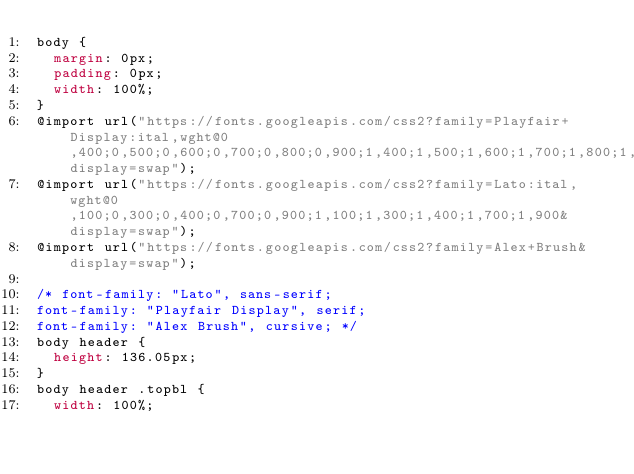Convert code to text. <code><loc_0><loc_0><loc_500><loc_500><_CSS_>body {
  margin: 0px;
  padding: 0px;
  width: 100%;
}
@import url("https://fonts.googleapis.com/css2?family=Playfair+Display:ital,wght@0,400;0,500;0,600;0,700;0,800;0,900;1,400;1,500;1,600;1,700;1,800;1,900&display=swap");
@import url("https://fonts.googleapis.com/css2?family=Lato:ital,wght@0,100;0,300;0,400;0,700;0,900;1,100;1,300;1,400;1,700;1,900&display=swap");
@import url("https://fonts.googleapis.com/css2?family=Alex+Brush&display=swap");

/* font-family: "Lato", sans-serif;
font-family: "Playfair Display", serif;
font-family: "Alex Brush", cursive; */
body header {
  height: 136.05px;
}
body header .topbl {
  width: 100%;</code> 